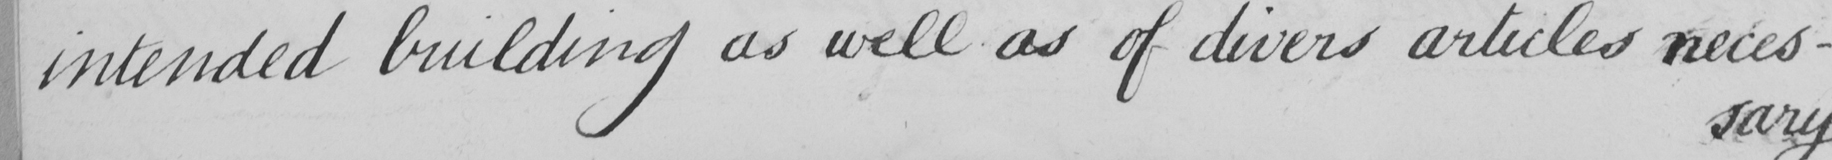What text is written in this handwritten line? intended building as well as of divers articles neces- 